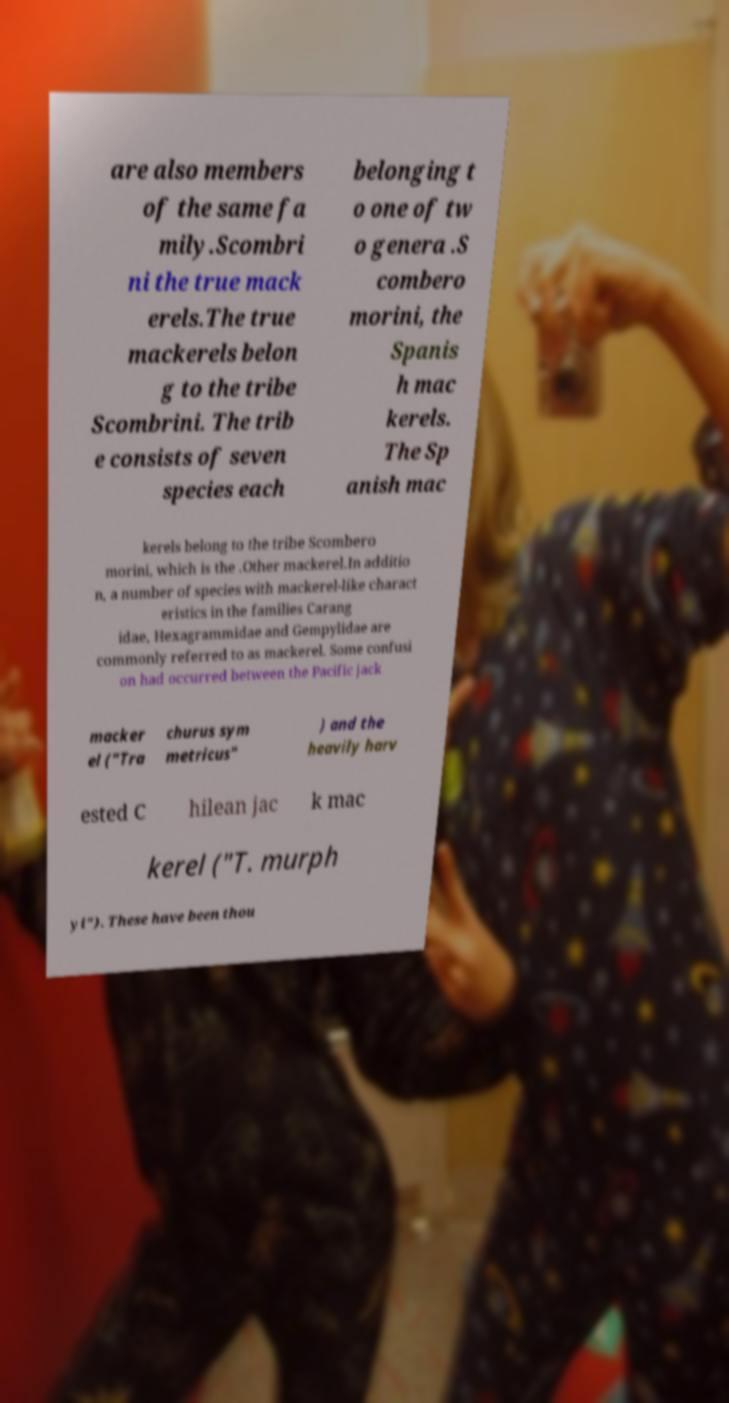For documentation purposes, I need the text within this image transcribed. Could you provide that? are also members of the same fa mily.Scombri ni the true mack erels.The true mackerels belon g to the tribe Scombrini. The trib e consists of seven species each belonging t o one of tw o genera .S combero morini, the Spanis h mac kerels. The Sp anish mac kerels belong to the tribe Scombero morini, which is the .Other mackerel.In additio n, a number of species with mackerel-like charact eristics in the families Carang idae, Hexagrammidae and Gempylidae are commonly referred to as mackerel. Some confusi on had occurred between the Pacific jack macker el ("Tra churus sym metricus" ) and the heavily harv ested C hilean jac k mac kerel ("T. murph yi"). These have been thou 